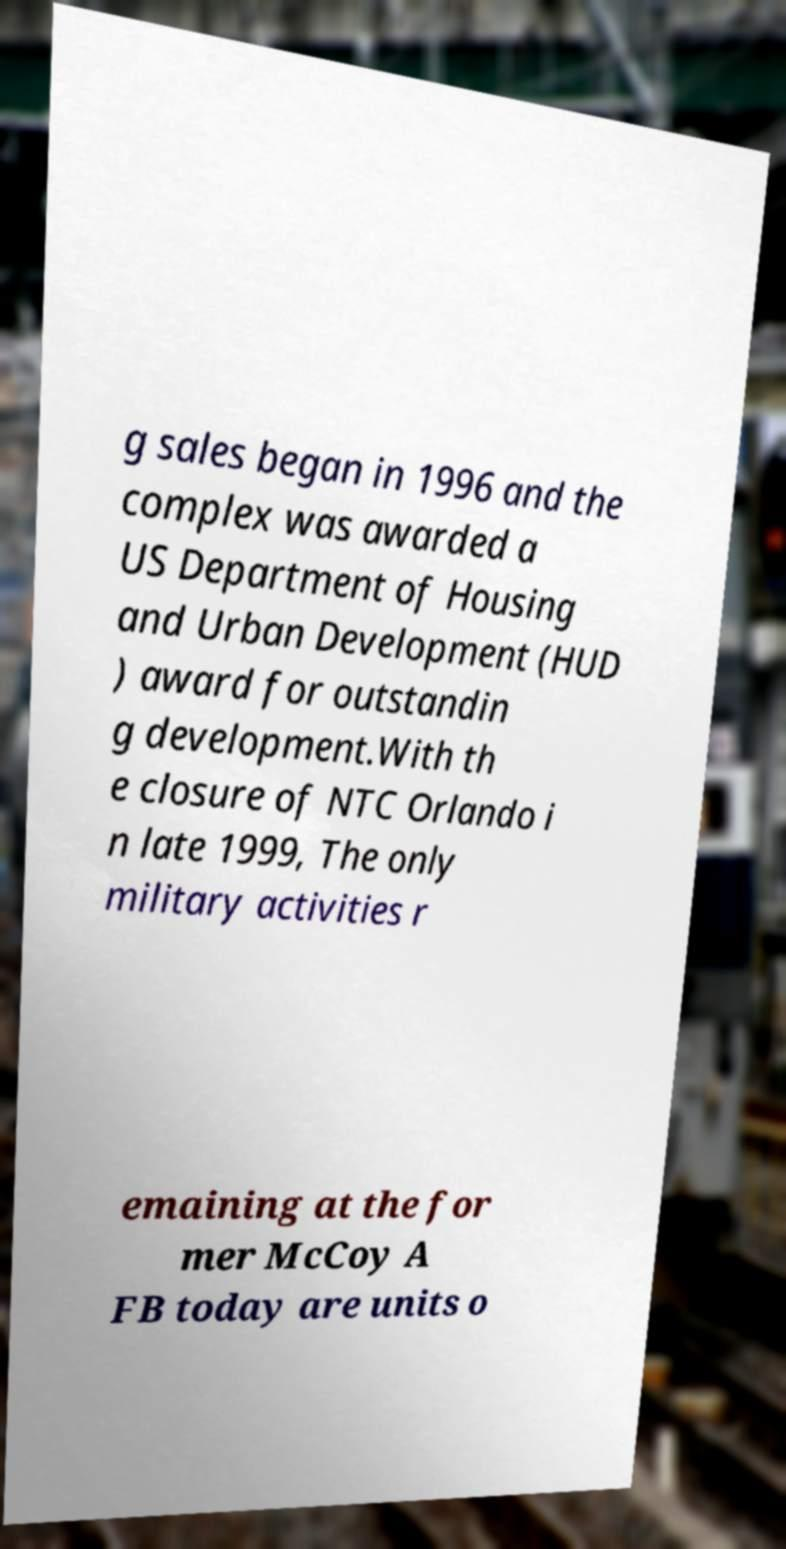There's text embedded in this image that I need extracted. Can you transcribe it verbatim? g sales began in 1996 and the complex was awarded a US Department of Housing and Urban Development (HUD ) award for outstandin g development.With th e closure of NTC Orlando i n late 1999, The only military activities r emaining at the for mer McCoy A FB today are units o 